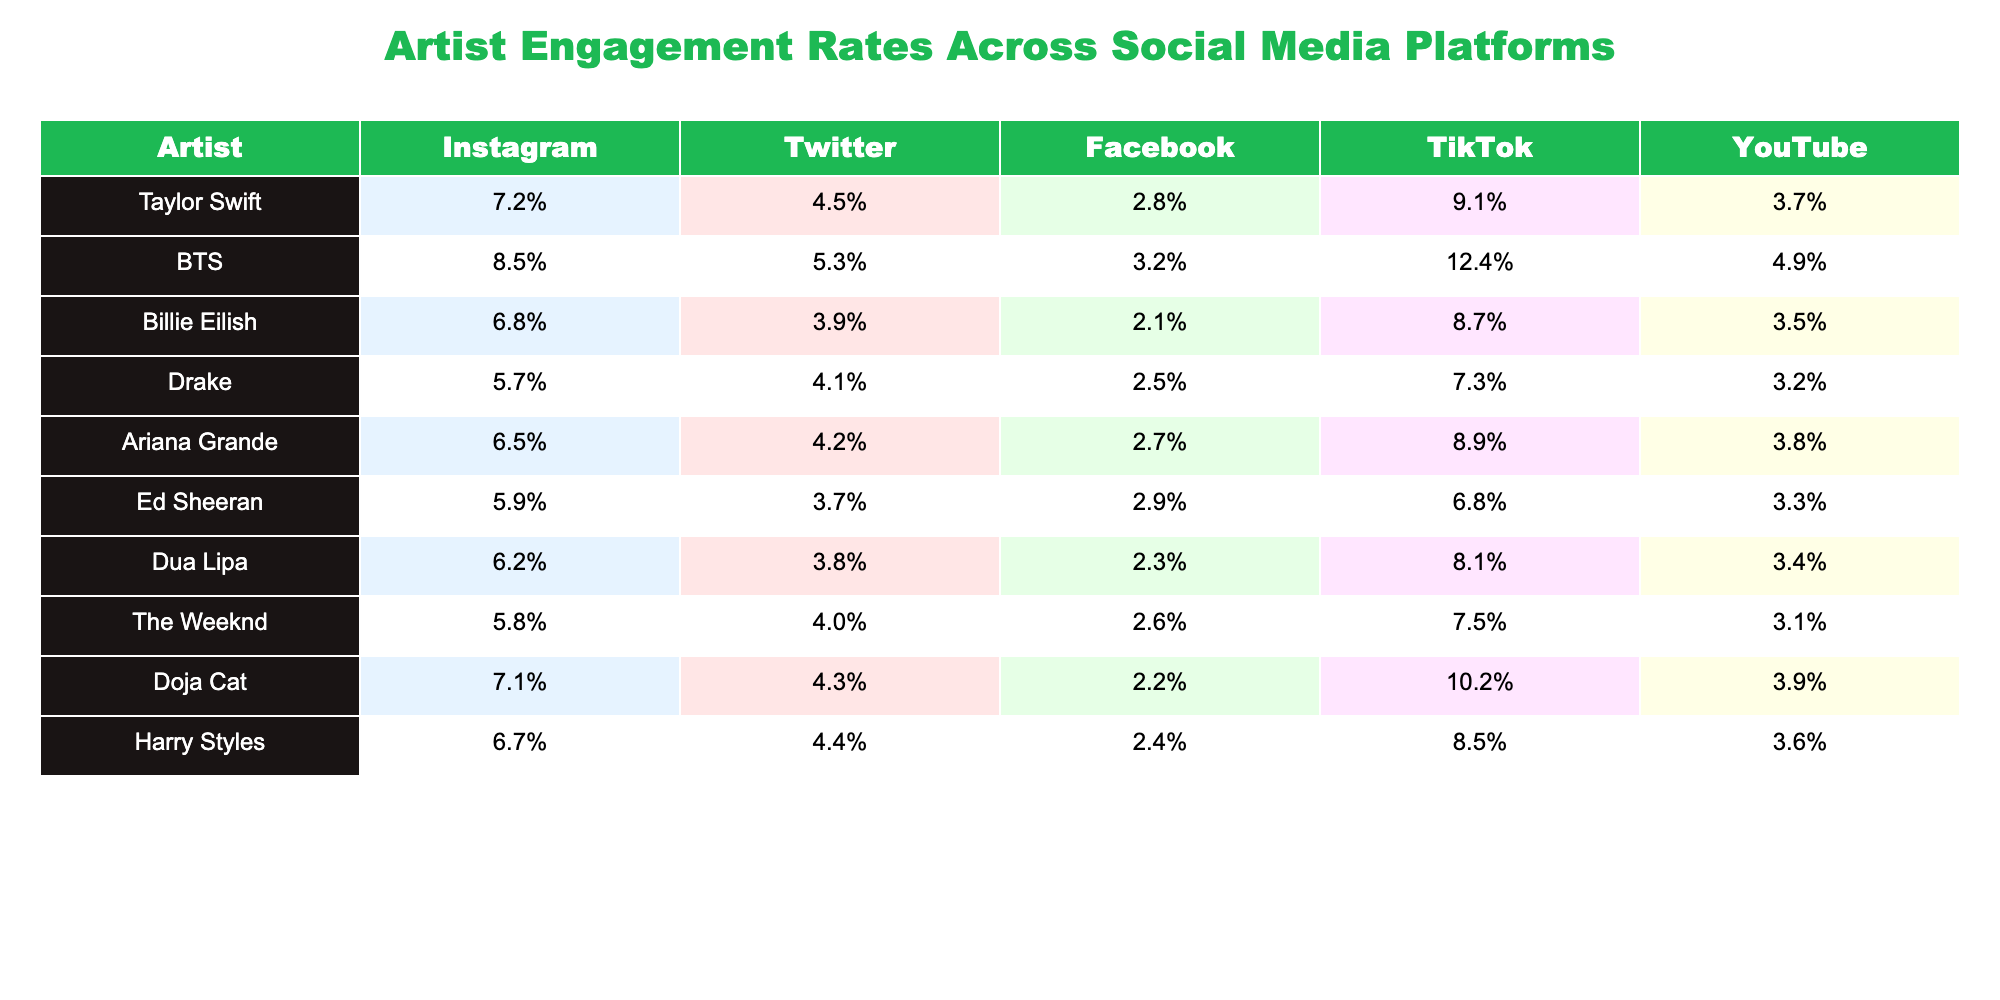What is the engagement rate of Taylor Swift on TikTok? The table shows that Taylor Swift has an engagement rate of 9.1% on TikTok.
Answer: 9.1% Which artist has the highest engagement rate on Instagram? According to the table, BTS has the highest engagement rate on Instagram at 8.5%.
Answer: BTS What is the difference in engagement rates on Facebook between Ed Sheeran and Doja Cat? Ed Sheeran has an engagement rate of 2.9% on Facebook, while Doja Cat has 2.2%. The difference is 2.9% - 2.2% = 0.7%.
Answer: 0.7% Which artist exhibits the lowest engagement rate on Facebook? From the table, Billie Eilish has the lowest engagement rate on Facebook at 2.1%.
Answer: Billie Eilish Calculate the average engagement rate on YouTube for the artists listed. Adding the YouTube engagement rates: (3.7% + 4.9% + 3.5% + 3.2% + 3.8% + 3.3% + 3.4% + 3.1% + 3.9% + 3.6%) = 35.4%. Dividing by the number of artists (10), the average is 3.54%.
Answer: 3.54% Is Ariana Grande's engagement rate on Instagram higher than Harry Styles'? Ariana Grande has an engagement rate of 6.5% on Instagram, while Harry Styles has 6.7%. Thus, Ariana Grande's rate is lower than Harry Styles'.
Answer: No Which artist has a higher average engagement rate across all platforms, Doja Cat or Drake? First, we calculate the average for both: Doja Cat: (7.1% + 4.3% + 2.2% + 10.2% + 3.9%) = 27.7%, divided by 5 gives 5.54%. Drake: (5.7% + 4.1% + 2.5% + 7.3% + 3.2%) = 22.8%, divided by 5 gives 4.56%. Doja Cat has the higher average.
Answer: Yes What percentage engagement does Billie Eilish have across all platforms combined? Summing Billie Eilish's engagement rates: 6.8% + 3.9% + 2.1% + 8.7% + 3.5% = 24.9%. Dividing by 5 gives an average of 4.98%.
Answer: 4.98% Does any artist have a higher engagement rate on TikTok compared to their engagement on Instagram? Checking the rates, we see that BTS has 8.5% on Instagram and 12.4% on TikTok, which is higher.
Answer: Yes Which artist's TikTok engagement is closest to their YouTube engagement? Both Doja Cat and Ariana Grande have TikTok engagement rates (10.2% and 8.9%) that are closer to their YouTube engagement (3.9% and 3.8%) than any other artist. The differences for both are 6.3% and 5.1%.
Answer: Doja Cat and Ariana Grande What is the sum of the lowest engagement rates across all platforms? The lowest engagement rates for each platform are: Instagram (5.7%), Twitter (3.9%), Facebook (2.1%), TikTok (5.7%), and YouTube (3.1%). Summing these gives: 5.7% + 3.9% + 2.1% + 5.7% + 3.1% = 20.5%.
Answer: 20.5% 